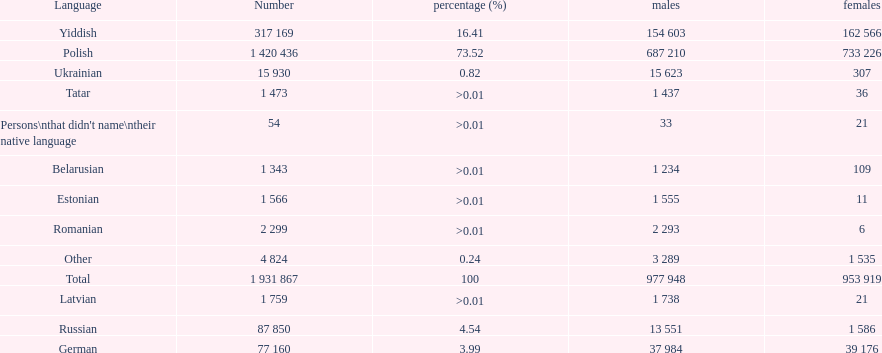Which language had the smallest number of females speaking it. Romanian. 